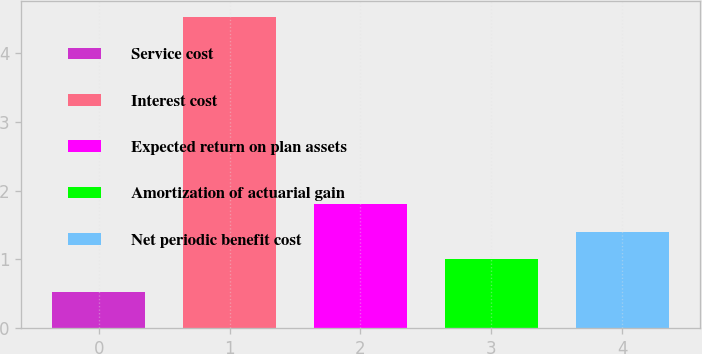<chart> <loc_0><loc_0><loc_500><loc_500><bar_chart><fcel>Service cost<fcel>Interest cost<fcel>Expected return on plan assets<fcel>Amortization of actuarial gain<fcel>Net periodic benefit cost<nl><fcel>0.53<fcel>4.53<fcel>1.8<fcel>1<fcel>1.4<nl></chart> 